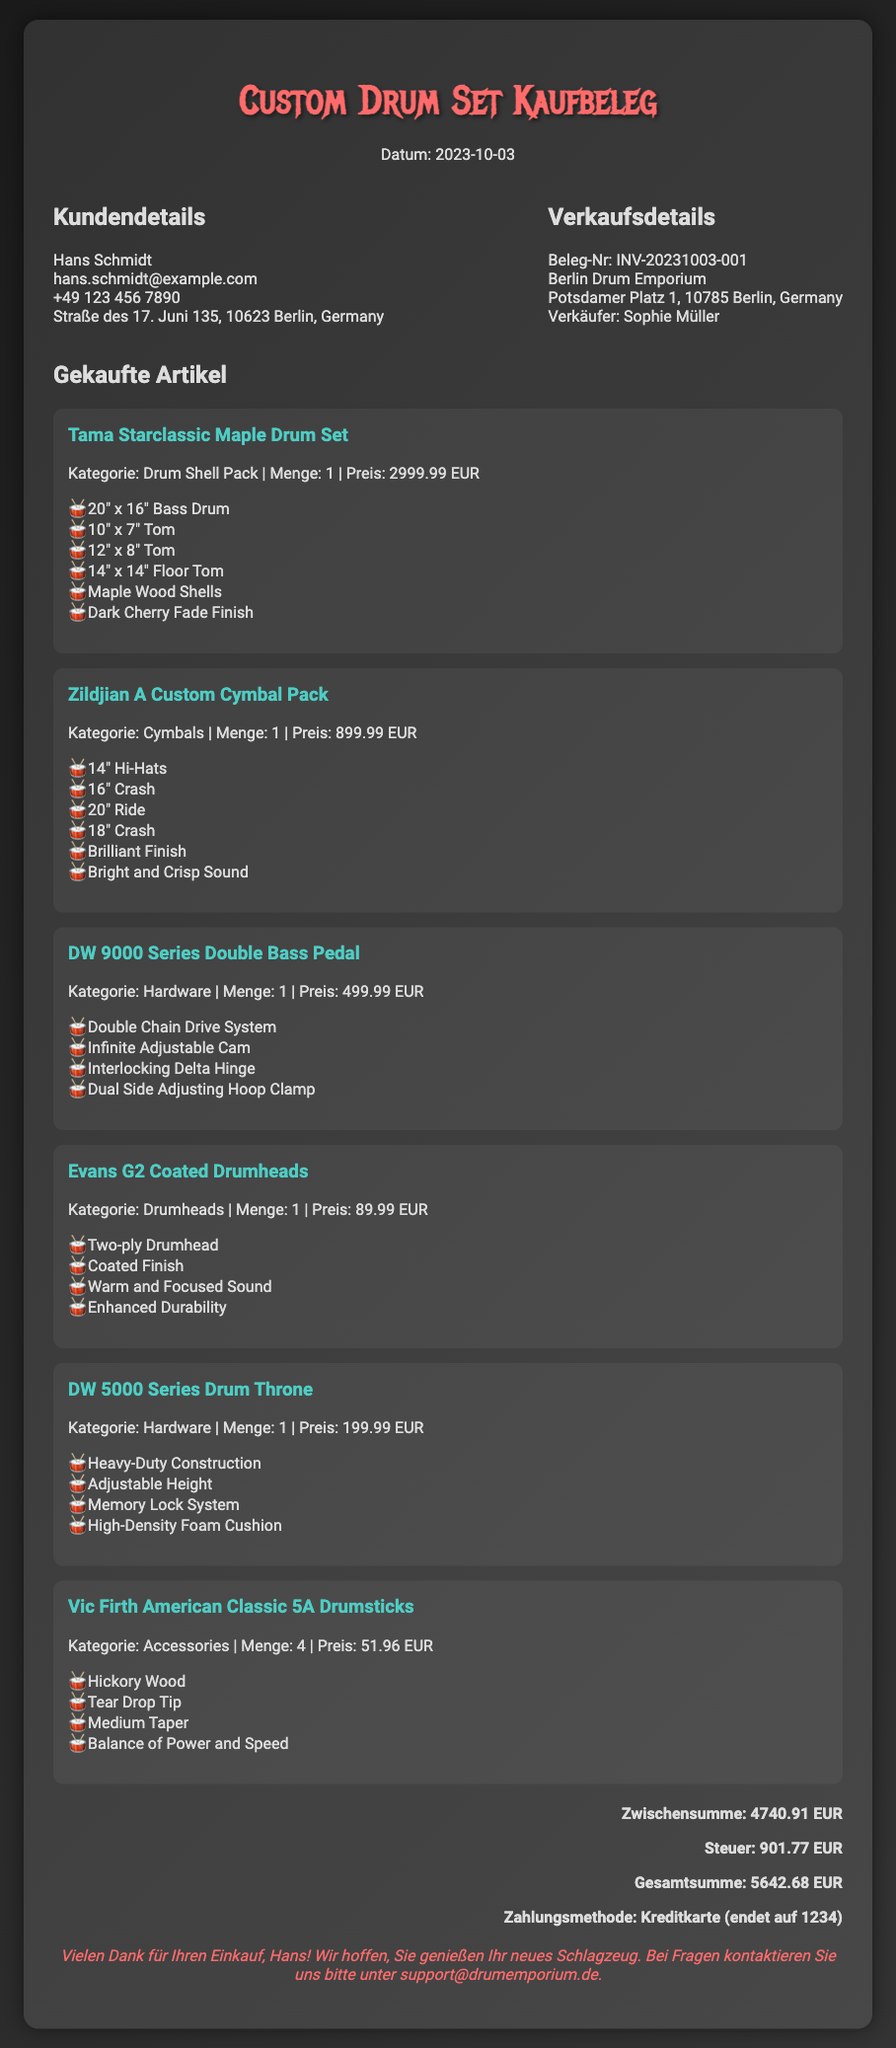Was ist das Datum des Kaufbelegs? Das Datum des Kaufbelegs wird im Dokument angezeigt und ist der Tag, an dem der Kauf stattgefunden hat.
Answer: 2023-10-03 Wer ist der Käufer? Der Käufer wird im Dokument unter den Kundendetails aufgeführt, was den Namen der Person betrifft.
Answer: Hans Schmidt Wie viel kostet das Tama Starclassic Maple Drum Set? Der Preis für das Tama Starclassic Maple Drum Set wird in der Auflistung der gekauften Artikel angezeigt.
Answer: 2999.99 EUR Welche Zahlungsart wurde verwendet? Die Zahlungsmethode ist am Ende des Dokuments aufgeführt und gibt an, wie die Bezahlung erfolgt ist.
Answer: Kreditkarte (endet auf 1234) Wie viel beträgt die Steuer? Die Steuern sind als separater Posten im Dokument hervorgehoben, was die berechnete Steuer beinhaltet.
Answer: 901.77 EUR Wie viele Schlagzeugstöcke wurden gekauft? Die Menge der Vic Firth American Classic 5A Drumsticks ist in der Artikelbeschreibung angegeben.
Answer: 4 Welche Art von Finish haben die Zildjian A Custom Cymbals? Das Finish der Zildjian A Custom Cymbals wird im Dokument unter den Artikelmerkmalen aufgeführt.
Answer: Brilliant Finish Name der Verkäuferin? Der Name der Verkäufers ist im Abschnitt für Verkaufsdetails angegeben.
Answer: Sophie Müller Was ist die Gesamtsumme der Rechnung? Die Gesamtsumme wird am Ende des Dokuments zusammengefasst und zeigt den Gesamtbetrag der Einkäufe an.
Answer: 5642.68 EUR 